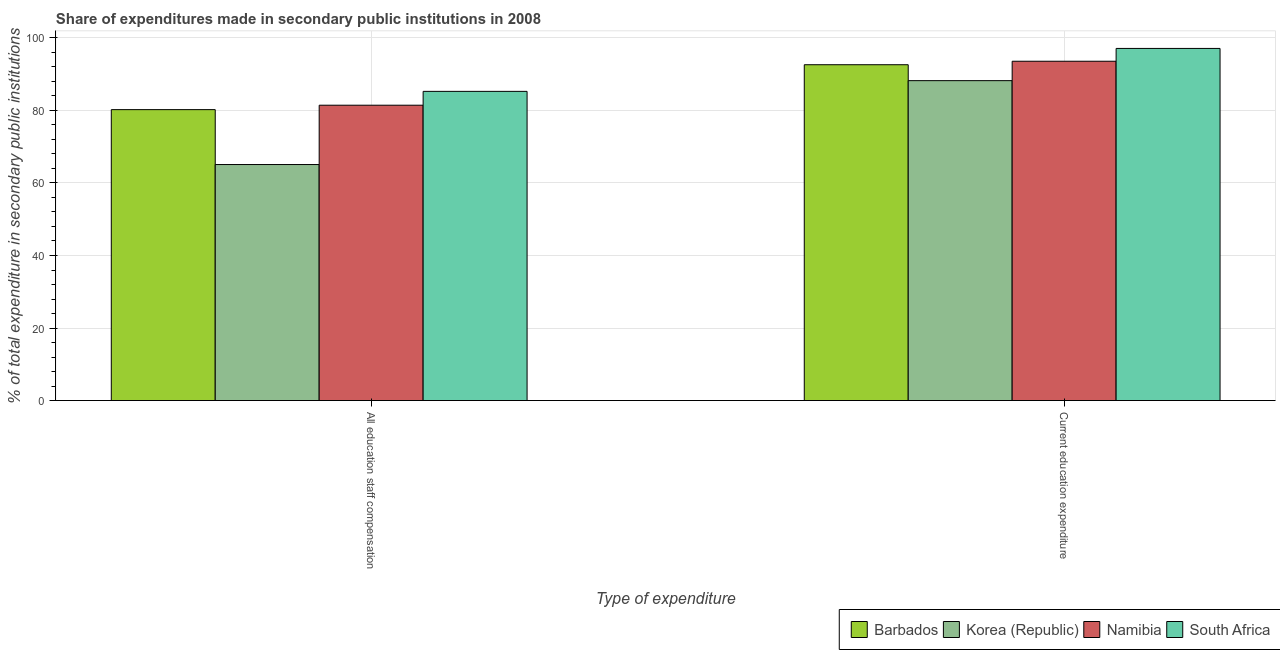How many different coloured bars are there?
Offer a terse response. 4. How many groups of bars are there?
Give a very brief answer. 2. How many bars are there on the 2nd tick from the right?
Make the answer very short. 4. What is the label of the 1st group of bars from the left?
Make the answer very short. All education staff compensation. What is the expenditure in education in Korea (Republic)?
Give a very brief answer. 88.2. Across all countries, what is the maximum expenditure in staff compensation?
Your response must be concise. 85.25. Across all countries, what is the minimum expenditure in education?
Give a very brief answer. 88.2. In which country was the expenditure in education maximum?
Provide a short and direct response. South Africa. What is the total expenditure in education in the graph?
Your answer should be very brief. 371.44. What is the difference between the expenditure in education in South Africa and that in Namibia?
Keep it short and to the point. 3.53. What is the difference between the expenditure in staff compensation in Korea (Republic) and the expenditure in education in Namibia?
Your answer should be very brief. -28.48. What is the average expenditure in education per country?
Make the answer very short. 92.86. What is the difference between the expenditure in education and expenditure in staff compensation in Barbados?
Offer a very short reply. 12.38. In how many countries, is the expenditure in staff compensation greater than 4 %?
Make the answer very short. 4. What is the ratio of the expenditure in education in Namibia to that in Korea (Republic)?
Keep it short and to the point. 1.06. What does the 3rd bar from the left in Current education expenditure represents?
Your response must be concise. Namibia. What does the 1st bar from the right in All education staff compensation represents?
Keep it short and to the point. South Africa. How many bars are there?
Ensure brevity in your answer.  8. How many countries are there in the graph?
Offer a very short reply. 4. What is the difference between two consecutive major ticks on the Y-axis?
Offer a terse response. 20. Does the graph contain any zero values?
Make the answer very short. No. Where does the legend appear in the graph?
Provide a succinct answer. Bottom right. What is the title of the graph?
Ensure brevity in your answer.  Share of expenditures made in secondary public institutions in 2008. What is the label or title of the X-axis?
Provide a succinct answer. Type of expenditure. What is the label or title of the Y-axis?
Provide a succinct answer. % of total expenditure in secondary public institutions. What is the % of total expenditure in secondary public institutions of Barbados in All education staff compensation?
Keep it short and to the point. 80.22. What is the % of total expenditure in secondary public institutions in Korea (Republic) in All education staff compensation?
Ensure brevity in your answer.  65.08. What is the % of total expenditure in secondary public institutions in Namibia in All education staff compensation?
Keep it short and to the point. 81.43. What is the % of total expenditure in secondary public institutions in South Africa in All education staff compensation?
Your answer should be compact. 85.25. What is the % of total expenditure in secondary public institutions of Barbados in Current education expenditure?
Provide a succinct answer. 92.59. What is the % of total expenditure in secondary public institutions in Korea (Republic) in Current education expenditure?
Make the answer very short. 88.2. What is the % of total expenditure in secondary public institutions of Namibia in Current education expenditure?
Give a very brief answer. 93.56. What is the % of total expenditure in secondary public institutions of South Africa in Current education expenditure?
Provide a short and direct response. 97.09. Across all Type of expenditure, what is the maximum % of total expenditure in secondary public institutions of Barbados?
Make the answer very short. 92.59. Across all Type of expenditure, what is the maximum % of total expenditure in secondary public institutions of Korea (Republic)?
Your answer should be very brief. 88.2. Across all Type of expenditure, what is the maximum % of total expenditure in secondary public institutions of Namibia?
Ensure brevity in your answer.  93.56. Across all Type of expenditure, what is the maximum % of total expenditure in secondary public institutions of South Africa?
Make the answer very short. 97.09. Across all Type of expenditure, what is the minimum % of total expenditure in secondary public institutions in Barbados?
Ensure brevity in your answer.  80.22. Across all Type of expenditure, what is the minimum % of total expenditure in secondary public institutions in Korea (Republic)?
Keep it short and to the point. 65.08. Across all Type of expenditure, what is the minimum % of total expenditure in secondary public institutions in Namibia?
Give a very brief answer. 81.43. Across all Type of expenditure, what is the minimum % of total expenditure in secondary public institutions of South Africa?
Offer a very short reply. 85.25. What is the total % of total expenditure in secondary public institutions of Barbados in the graph?
Give a very brief answer. 172.81. What is the total % of total expenditure in secondary public institutions of Korea (Republic) in the graph?
Your response must be concise. 153.28. What is the total % of total expenditure in secondary public institutions of Namibia in the graph?
Offer a very short reply. 174.99. What is the total % of total expenditure in secondary public institutions in South Africa in the graph?
Your answer should be very brief. 182.34. What is the difference between the % of total expenditure in secondary public institutions of Barbados in All education staff compensation and that in Current education expenditure?
Ensure brevity in your answer.  -12.38. What is the difference between the % of total expenditure in secondary public institutions in Korea (Republic) in All education staff compensation and that in Current education expenditure?
Make the answer very short. -23.13. What is the difference between the % of total expenditure in secondary public institutions of Namibia in All education staff compensation and that in Current education expenditure?
Provide a succinct answer. -12.13. What is the difference between the % of total expenditure in secondary public institutions in South Africa in All education staff compensation and that in Current education expenditure?
Keep it short and to the point. -11.84. What is the difference between the % of total expenditure in secondary public institutions of Barbados in All education staff compensation and the % of total expenditure in secondary public institutions of Korea (Republic) in Current education expenditure?
Provide a short and direct response. -7.99. What is the difference between the % of total expenditure in secondary public institutions of Barbados in All education staff compensation and the % of total expenditure in secondary public institutions of Namibia in Current education expenditure?
Provide a short and direct response. -13.34. What is the difference between the % of total expenditure in secondary public institutions of Barbados in All education staff compensation and the % of total expenditure in secondary public institutions of South Africa in Current education expenditure?
Make the answer very short. -16.87. What is the difference between the % of total expenditure in secondary public institutions of Korea (Republic) in All education staff compensation and the % of total expenditure in secondary public institutions of Namibia in Current education expenditure?
Give a very brief answer. -28.48. What is the difference between the % of total expenditure in secondary public institutions in Korea (Republic) in All education staff compensation and the % of total expenditure in secondary public institutions in South Africa in Current education expenditure?
Your answer should be compact. -32.01. What is the difference between the % of total expenditure in secondary public institutions of Namibia in All education staff compensation and the % of total expenditure in secondary public institutions of South Africa in Current education expenditure?
Give a very brief answer. -15.66. What is the average % of total expenditure in secondary public institutions of Barbados per Type of expenditure?
Give a very brief answer. 86.4. What is the average % of total expenditure in secondary public institutions in Korea (Republic) per Type of expenditure?
Keep it short and to the point. 76.64. What is the average % of total expenditure in secondary public institutions in Namibia per Type of expenditure?
Offer a very short reply. 87.49. What is the average % of total expenditure in secondary public institutions of South Africa per Type of expenditure?
Your answer should be very brief. 91.17. What is the difference between the % of total expenditure in secondary public institutions of Barbados and % of total expenditure in secondary public institutions of Korea (Republic) in All education staff compensation?
Make the answer very short. 15.14. What is the difference between the % of total expenditure in secondary public institutions of Barbados and % of total expenditure in secondary public institutions of Namibia in All education staff compensation?
Provide a succinct answer. -1.22. What is the difference between the % of total expenditure in secondary public institutions in Barbados and % of total expenditure in secondary public institutions in South Africa in All education staff compensation?
Offer a terse response. -5.04. What is the difference between the % of total expenditure in secondary public institutions of Korea (Republic) and % of total expenditure in secondary public institutions of Namibia in All education staff compensation?
Provide a succinct answer. -16.36. What is the difference between the % of total expenditure in secondary public institutions of Korea (Republic) and % of total expenditure in secondary public institutions of South Africa in All education staff compensation?
Provide a succinct answer. -20.17. What is the difference between the % of total expenditure in secondary public institutions of Namibia and % of total expenditure in secondary public institutions of South Africa in All education staff compensation?
Provide a succinct answer. -3.82. What is the difference between the % of total expenditure in secondary public institutions in Barbados and % of total expenditure in secondary public institutions in Korea (Republic) in Current education expenditure?
Ensure brevity in your answer.  4.39. What is the difference between the % of total expenditure in secondary public institutions of Barbados and % of total expenditure in secondary public institutions of Namibia in Current education expenditure?
Offer a terse response. -0.96. What is the difference between the % of total expenditure in secondary public institutions in Barbados and % of total expenditure in secondary public institutions in South Africa in Current education expenditure?
Provide a succinct answer. -4.49. What is the difference between the % of total expenditure in secondary public institutions of Korea (Republic) and % of total expenditure in secondary public institutions of Namibia in Current education expenditure?
Make the answer very short. -5.35. What is the difference between the % of total expenditure in secondary public institutions in Korea (Republic) and % of total expenditure in secondary public institutions in South Africa in Current education expenditure?
Make the answer very short. -8.88. What is the difference between the % of total expenditure in secondary public institutions in Namibia and % of total expenditure in secondary public institutions in South Africa in Current education expenditure?
Your response must be concise. -3.53. What is the ratio of the % of total expenditure in secondary public institutions of Barbados in All education staff compensation to that in Current education expenditure?
Provide a succinct answer. 0.87. What is the ratio of the % of total expenditure in secondary public institutions of Korea (Republic) in All education staff compensation to that in Current education expenditure?
Give a very brief answer. 0.74. What is the ratio of the % of total expenditure in secondary public institutions of Namibia in All education staff compensation to that in Current education expenditure?
Your response must be concise. 0.87. What is the ratio of the % of total expenditure in secondary public institutions of South Africa in All education staff compensation to that in Current education expenditure?
Provide a short and direct response. 0.88. What is the difference between the highest and the second highest % of total expenditure in secondary public institutions of Barbados?
Keep it short and to the point. 12.38. What is the difference between the highest and the second highest % of total expenditure in secondary public institutions in Korea (Republic)?
Give a very brief answer. 23.13. What is the difference between the highest and the second highest % of total expenditure in secondary public institutions in Namibia?
Your answer should be compact. 12.13. What is the difference between the highest and the second highest % of total expenditure in secondary public institutions of South Africa?
Keep it short and to the point. 11.84. What is the difference between the highest and the lowest % of total expenditure in secondary public institutions in Barbados?
Give a very brief answer. 12.38. What is the difference between the highest and the lowest % of total expenditure in secondary public institutions in Korea (Republic)?
Make the answer very short. 23.13. What is the difference between the highest and the lowest % of total expenditure in secondary public institutions of Namibia?
Give a very brief answer. 12.13. What is the difference between the highest and the lowest % of total expenditure in secondary public institutions in South Africa?
Make the answer very short. 11.84. 